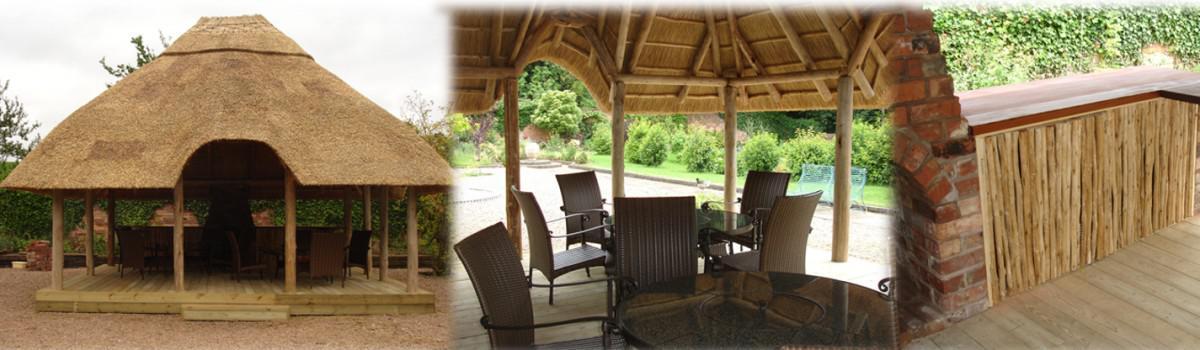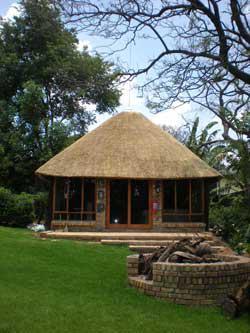The first image is the image on the left, the second image is the image on the right. Examine the images to the left and right. Is the description "In one of the images, you can see a man-made pool just in front of the dwelling." accurate? Answer yes or no. No. The first image is the image on the left, the second image is the image on the right. Assess this claim about the two images: "There is a pool in one image and not the other.". Correct or not? Answer yes or no. No. 